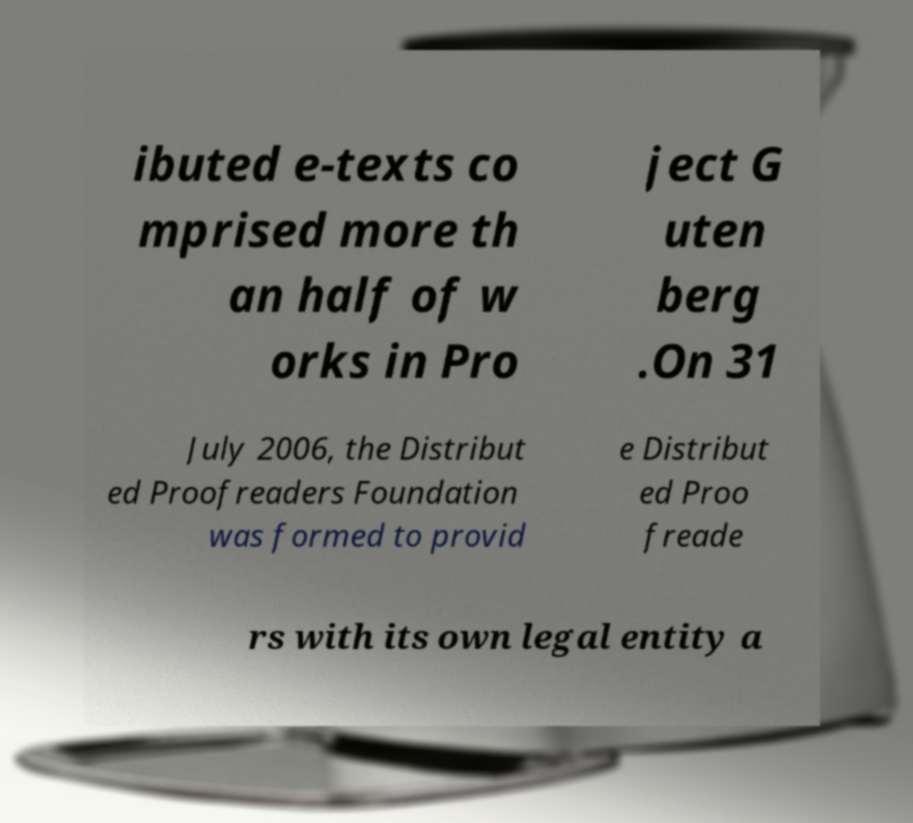For documentation purposes, I need the text within this image transcribed. Could you provide that? ibuted e-texts co mprised more th an half of w orks in Pro ject G uten berg .On 31 July 2006, the Distribut ed Proofreaders Foundation was formed to provid e Distribut ed Proo freade rs with its own legal entity a 